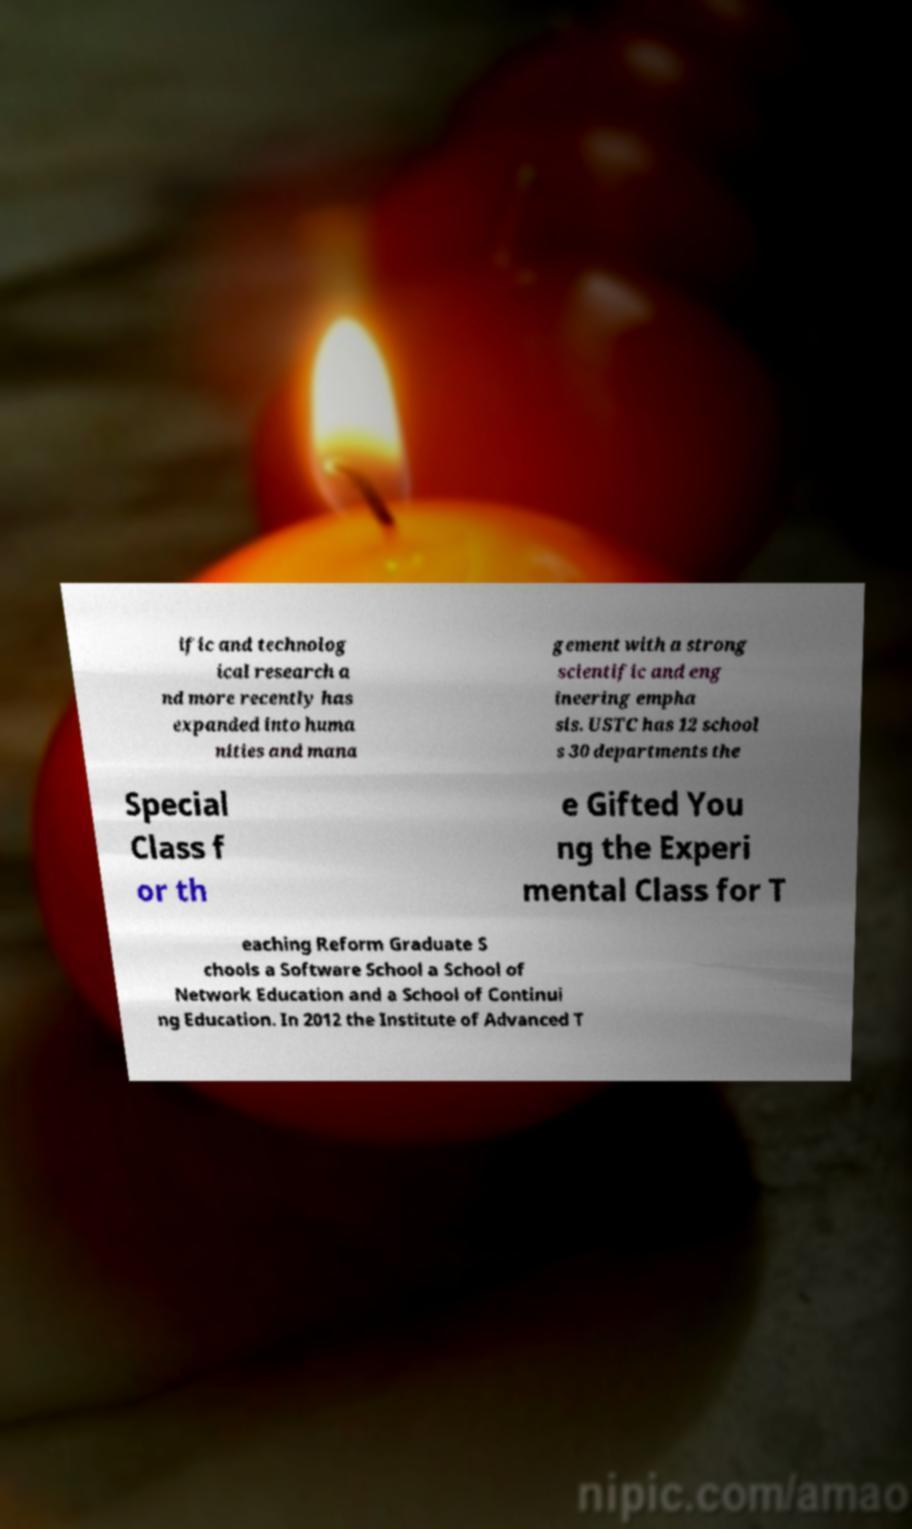I need the written content from this picture converted into text. Can you do that? ific and technolog ical research a nd more recently has expanded into huma nities and mana gement with a strong scientific and eng ineering empha sis. USTC has 12 school s 30 departments the Special Class f or th e Gifted You ng the Experi mental Class for T eaching Reform Graduate S chools a Software School a School of Network Education and a School of Continui ng Education. In 2012 the Institute of Advanced T 